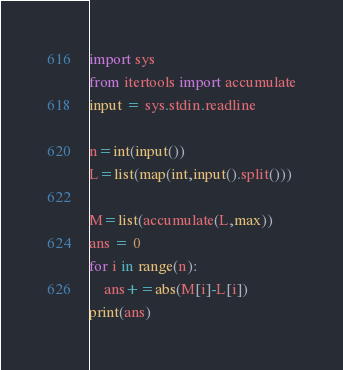<code> <loc_0><loc_0><loc_500><loc_500><_Python_>import sys
from itertools import accumulate
input = sys.stdin.readline

n=int(input())
L=list(map(int,input().split()))

M=list(accumulate(L,max))
ans = 0
for i in range(n):
    ans+=abs(M[i]-L[i])
print(ans)




</code> 